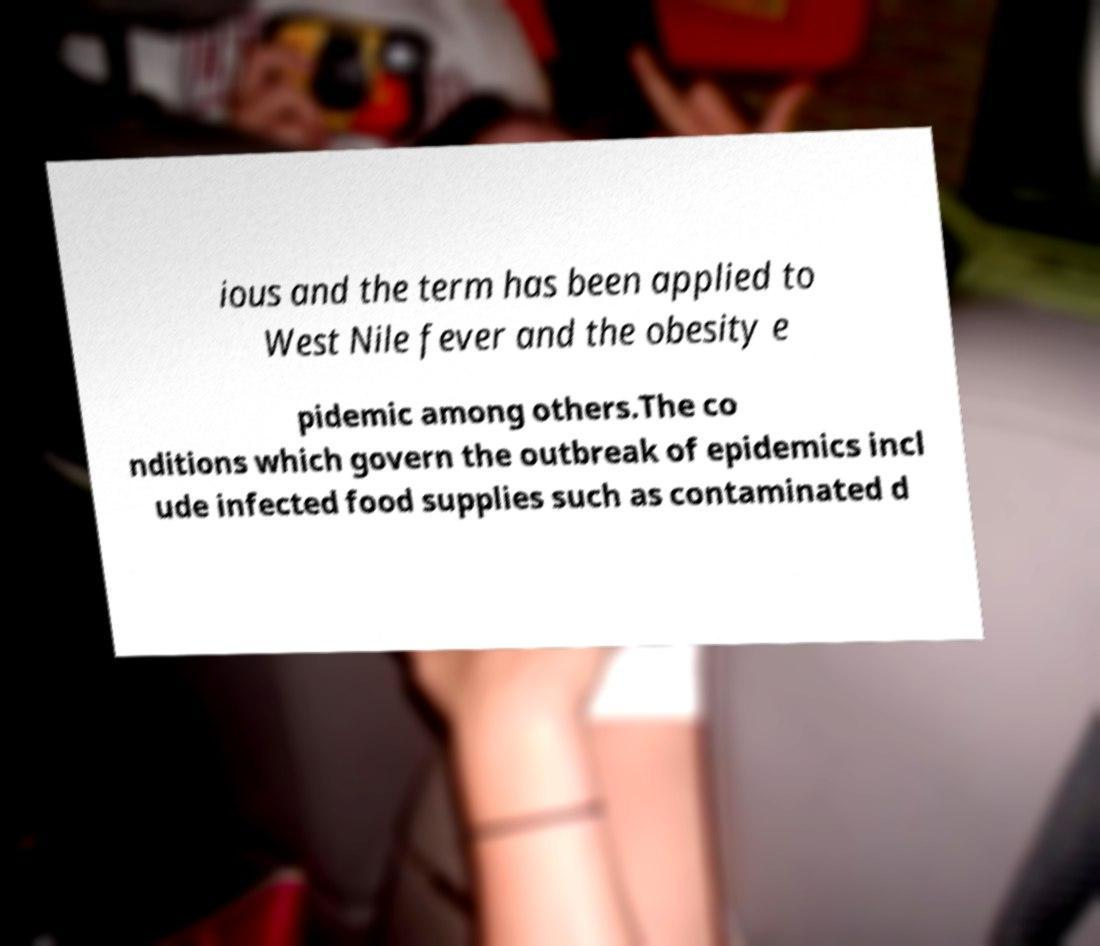Please read and relay the text visible in this image. What does it say? ious and the term has been applied to West Nile fever and the obesity e pidemic among others.The co nditions which govern the outbreak of epidemics incl ude infected food supplies such as contaminated d 